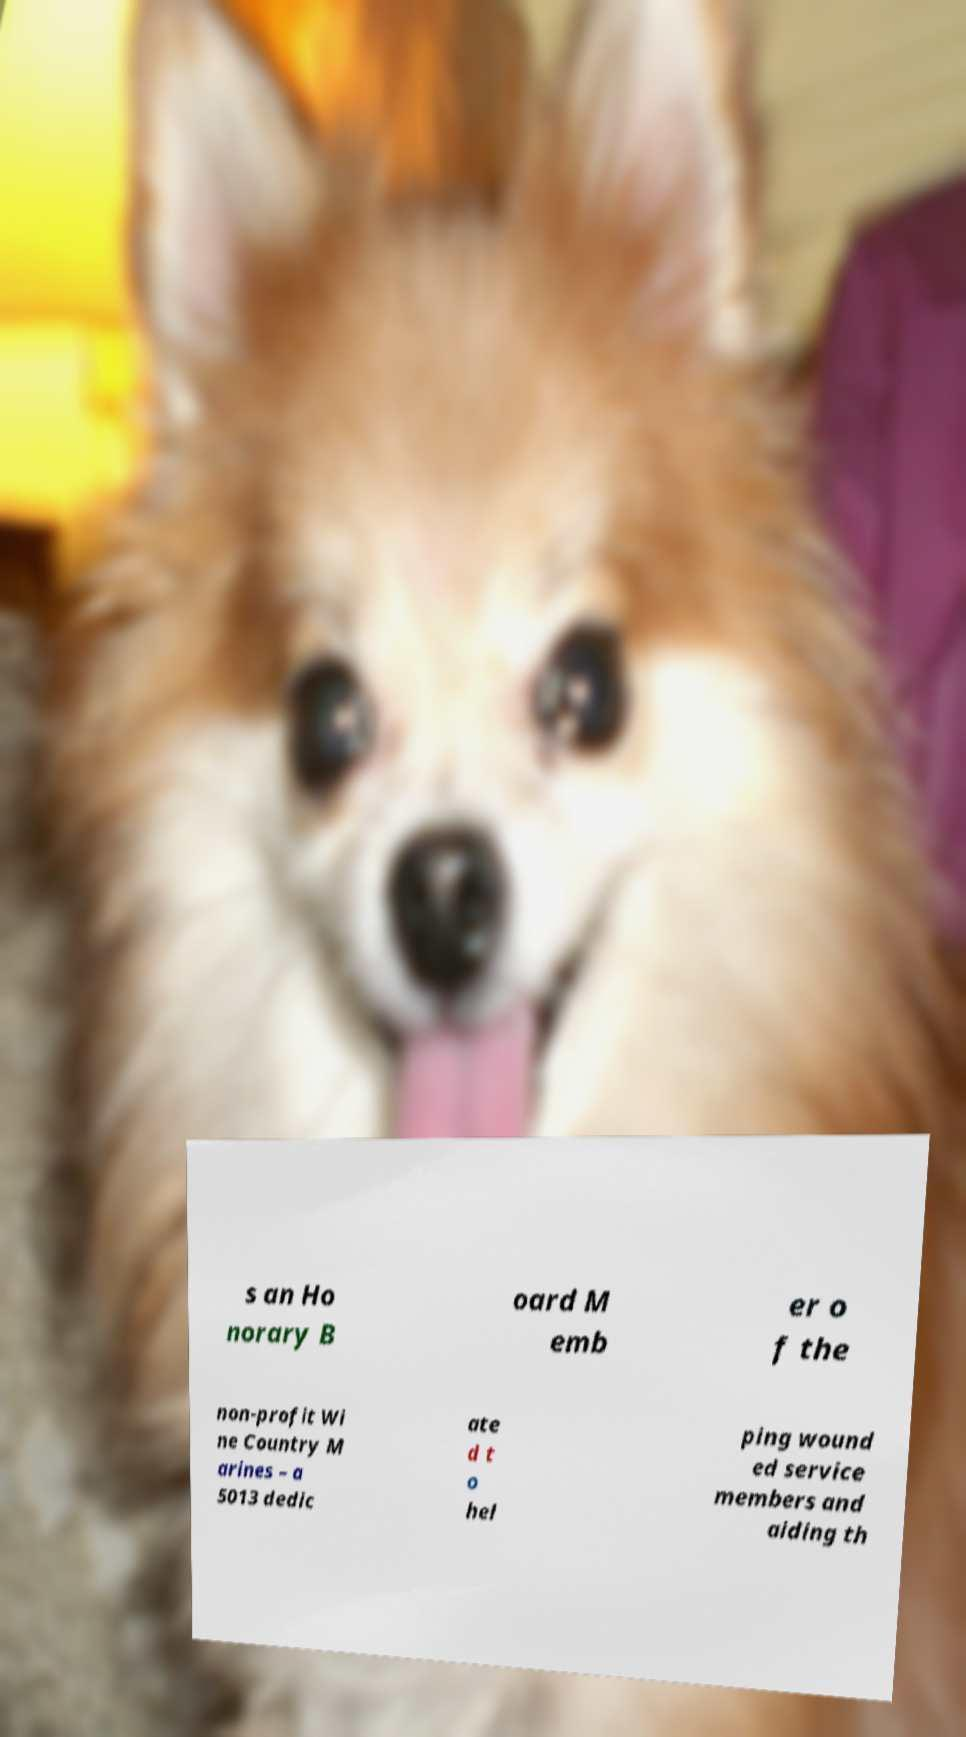Can you read and provide the text displayed in the image?This photo seems to have some interesting text. Can you extract and type it out for me? s an Ho norary B oard M emb er o f the non-profit Wi ne Country M arines – a 5013 dedic ate d t o hel ping wound ed service members and aiding th 